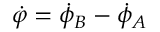Convert formula to latex. <formula><loc_0><loc_0><loc_500><loc_500>{ \dot { \varphi } } = { \dot { \phi } } _ { B } - { \dot { \phi } } _ { A }</formula> 